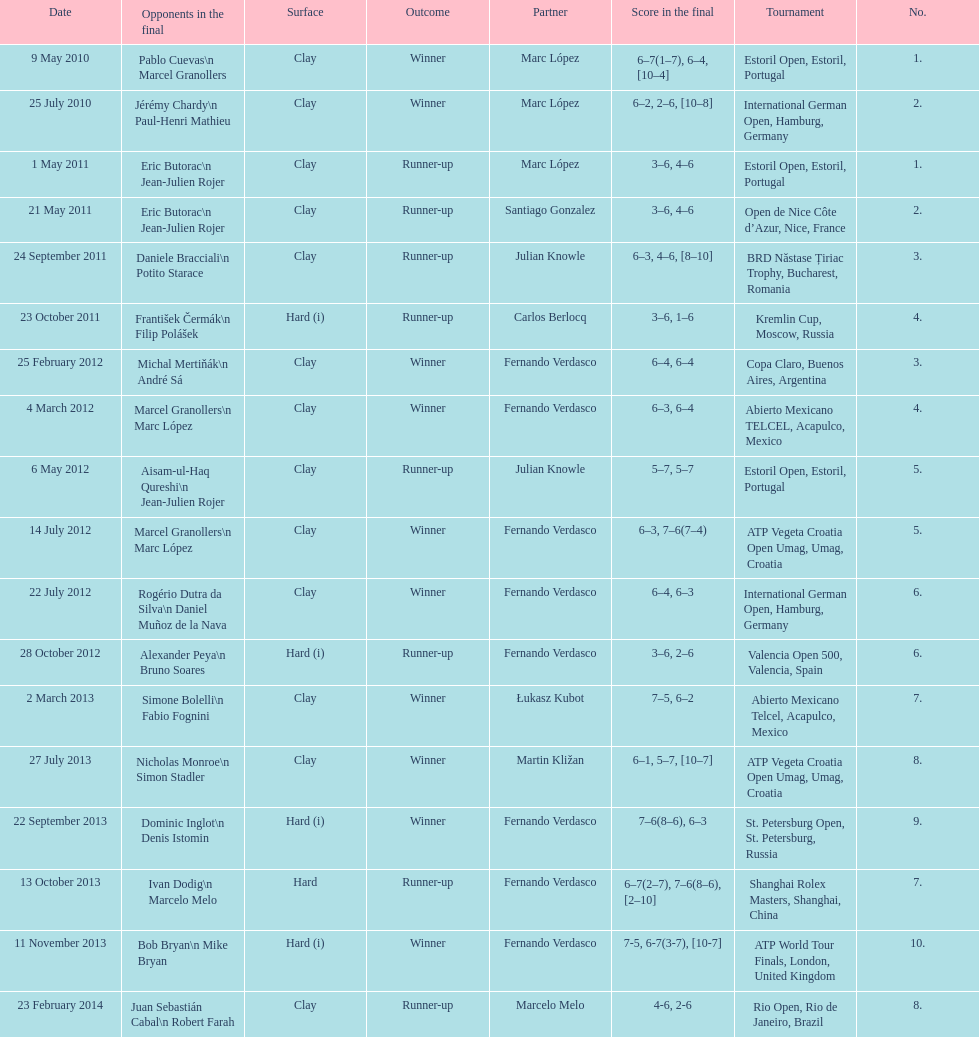Who was this player's next partner after playing with marc lopez in may 2011? Santiago Gonzalez. 